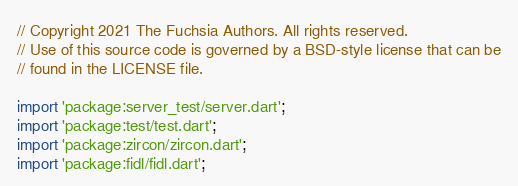Convert code to text. <code><loc_0><loc_0><loc_500><loc_500><_Dart_>// Copyright 2021 The Fuchsia Authors. All rights reserved.
// Use of this source code is governed by a BSD-style license that can be
// found in the LICENSE file.

import 'package:server_test/server.dart';
import 'package:test/test.dart';
import 'package:zircon/zircon.dart';
import 'package:fidl/fidl.dart';
</code> 